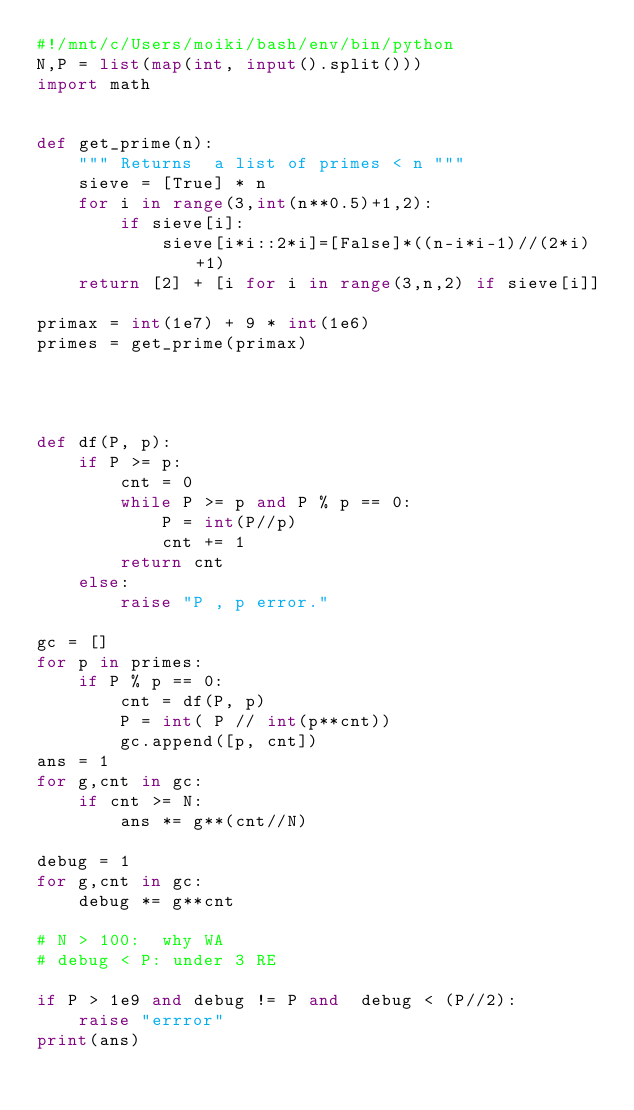<code> <loc_0><loc_0><loc_500><loc_500><_Python_>#!/mnt/c/Users/moiki/bash/env/bin/python
N,P = list(map(int, input().split()))
import math


def get_prime(n):
    """ Returns  a list of primes < n """
    sieve = [True] * n
    for i in range(3,int(n**0.5)+1,2):
        if sieve[i]:
            sieve[i*i::2*i]=[False]*((n-i*i-1)//(2*i)+1)
    return [2] + [i for i in range(3,n,2) if sieve[i]]

primax = int(1e7) + 9 * int(1e6)
primes = get_prime(primax)




def df(P, p):
    if P >= p:
        cnt = 0
        while P >= p and P % p == 0:
            P = int(P//p)
            cnt += 1
        return cnt
    else:
        raise "P , p error."

gc = []
for p in primes:
    if P % p == 0:
        cnt = df(P, p)
        P = int( P // int(p**cnt))
        gc.append([p, cnt])
ans = 1
for g,cnt in gc:
    if cnt >= N:
        ans *= g**(cnt//N)

debug = 1
for g,cnt in gc:
    debug *= g**cnt

# N > 100:  why WA
# debug < P: under 3 RE

if P > 1e9 and debug != P and  debug < (P//2):
    raise "errror"
print(ans)
</code> 